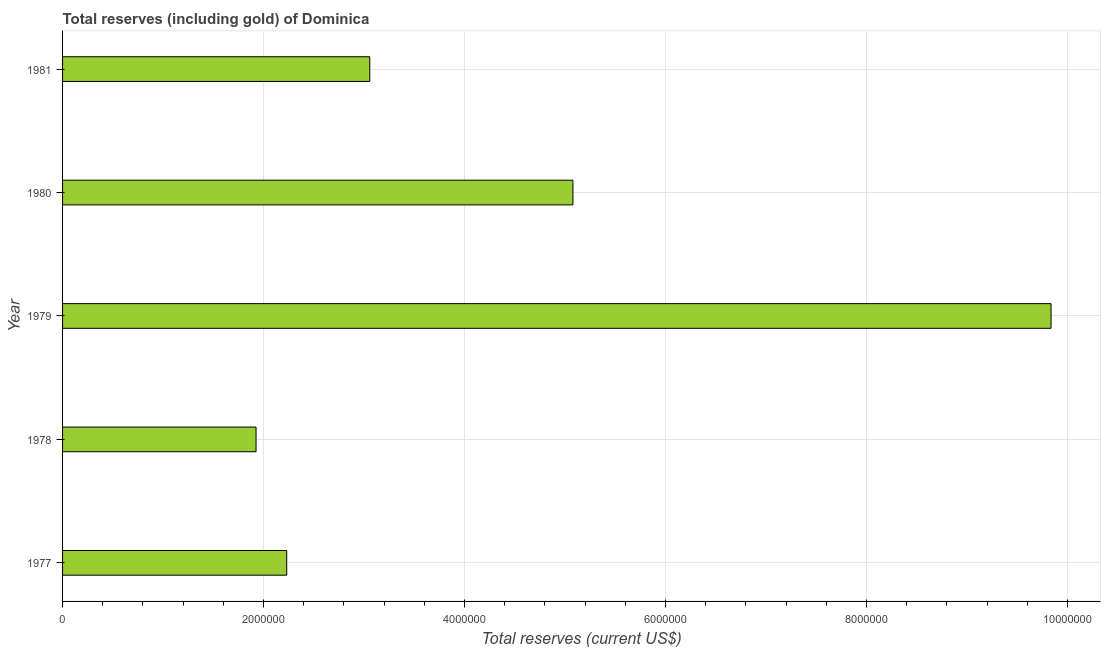Does the graph contain any zero values?
Your answer should be compact. No. What is the title of the graph?
Make the answer very short. Total reserves (including gold) of Dominica. What is the label or title of the X-axis?
Ensure brevity in your answer.  Total reserves (current US$). What is the total reserves (including gold) in 1980?
Offer a very short reply. 5.08e+06. Across all years, what is the maximum total reserves (including gold)?
Your answer should be compact. 9.84e+06. Across all years, what is the minimum total reserves (including gold)?
Provide a short and direct response. 1.93e+06. In which year was the total reserves (including gold) maximum?
Provide a short and direct response. 1979. In which year was the total reserves (including gold) minimum?
Your answer should be compact. 1978. What is the sum of the total reserves (including gold)?
Give a very brief answer. 2.21e+07. What is the difference between the total reserves (including gold) in 1978 and 1980?
Your answer should be compact. -3.15e+06. What is the average total reserves (including gold) per year?
Your answer should be very brief. 4.43e+06. What is the median total reserves (including gold)?
Ensure brevity in your answer.  3.06e+06. What is the ratio of the total reserves (including gold) in 1977 to that in 1981?
Offer a terse response. 0.73. What is the difference between the highest and the second highest total reserves (including gold)?
Your answer should be very brief. 4.76e+06. What is the difference between the highest and the lowest total reserves (including gold)?
Provide a short and direct response. 7.91e+06. In how many years, is the total reserves (including gold) greater than the average total reserves (including gold) taken over all years?
Offer a very short reply. 2. How many bars are there?
Keep it short and to the point. 5. Are the values on the major ticks of X-axis written in scientific E-notation?
Keep it short and to the point. No. What is the Total reserves (current US$) in 1977?
Keep it short and to the point. 2.23e+06. What is the Total reserves (current US$) in 1978?
Provide a succinct answer. 1.93e+06. What is the Total reserves (current US$) in 1979?
Your answer should be compact. 9.84e+06. What is the Total reserves (current US$) of 1980?
Ensure brevity in your answer.  5.08e+06. What is the Total reserves (current US$) in 1981?
Offer a very short reply. 3.06e+06. What is the difference between the Total reserves (current US$) in 1977 and 1978?
Your answer should be compact. 3.05e+05. What is the difference between the Total reserves (current US$) in 1977 and 1979?
Your answer should be very brief. -7.61e+06. What is the difference between the Total reserves (current US$) in 1977 and 1980?
Keep it short and to the point. -2.85e+06. What is the difference between the Total reserves (current US$) in 1977 and 1981?
Keep it short and to the point. -8.27e+05. What is the difference between the Total reserves (current US$) in 1978 and 1979?
Provide a short and direct response. -7.91e+06. What is the difference between the Total reserves (current US$) in 1978 and 1980?
Give a very brief answer. -3.15e+06. What is the difference between the Total reserves (current US$) in 1978 and 1981?
Give a very brief answer. -1.13e+06. What is the difference between the Total reserves (current US$) in 1979 and 1980?
Ensure brevity in your answer.  4.76e+06. What is the difference between the Total reserves (current US$) in 1979 and 1981?
Keep it short and to the point. 6.78e+06. What is the difference between the Total reserves (current US$) in 1980 and 1981?
Make the answer very short. 2.02e+06. What is the ratio of the Total reserves (current US$) in 1977 to that in 1978?
Keep it short and to the point. 1.16. What is the ratio of the Total reserves (current US$) in 1977 to that in 1979?
Your answer should be very brief. 0.23. What is the ratio of the Total reserves (current US$) in 1977 to that in 1980?
Your answer should be compact. 0.44. What is the ratio of the Total reserves (current US$) in 1977 to that in 1981?
Offer a terse response. 0.73. What is the ratio of the Total reserves (current US$) in 1978 to that in 1979?
Provide a short and direct response. 0.2. What is the ratio of the Total reserves (current US$) in 1978 to that in 1980?
Provide a short and direct response. 0.38. What is the ratio of the Total reserves (current US$) in 1978 to that in 1981?
Provide a succinct answer. 0.63. What is the ratio of the Total reserves (current US$) in 1979 to that in 1980?
Offer a terse response. 1.94. What is the ratio of the Total reserves (current US$) in 1979 to that in 1981?
Your response must be concise. 3.22. What is the ratio of the Total reserves (current US$) in 1980 to that in 1981?
Offer a very short reply. 1.66. 